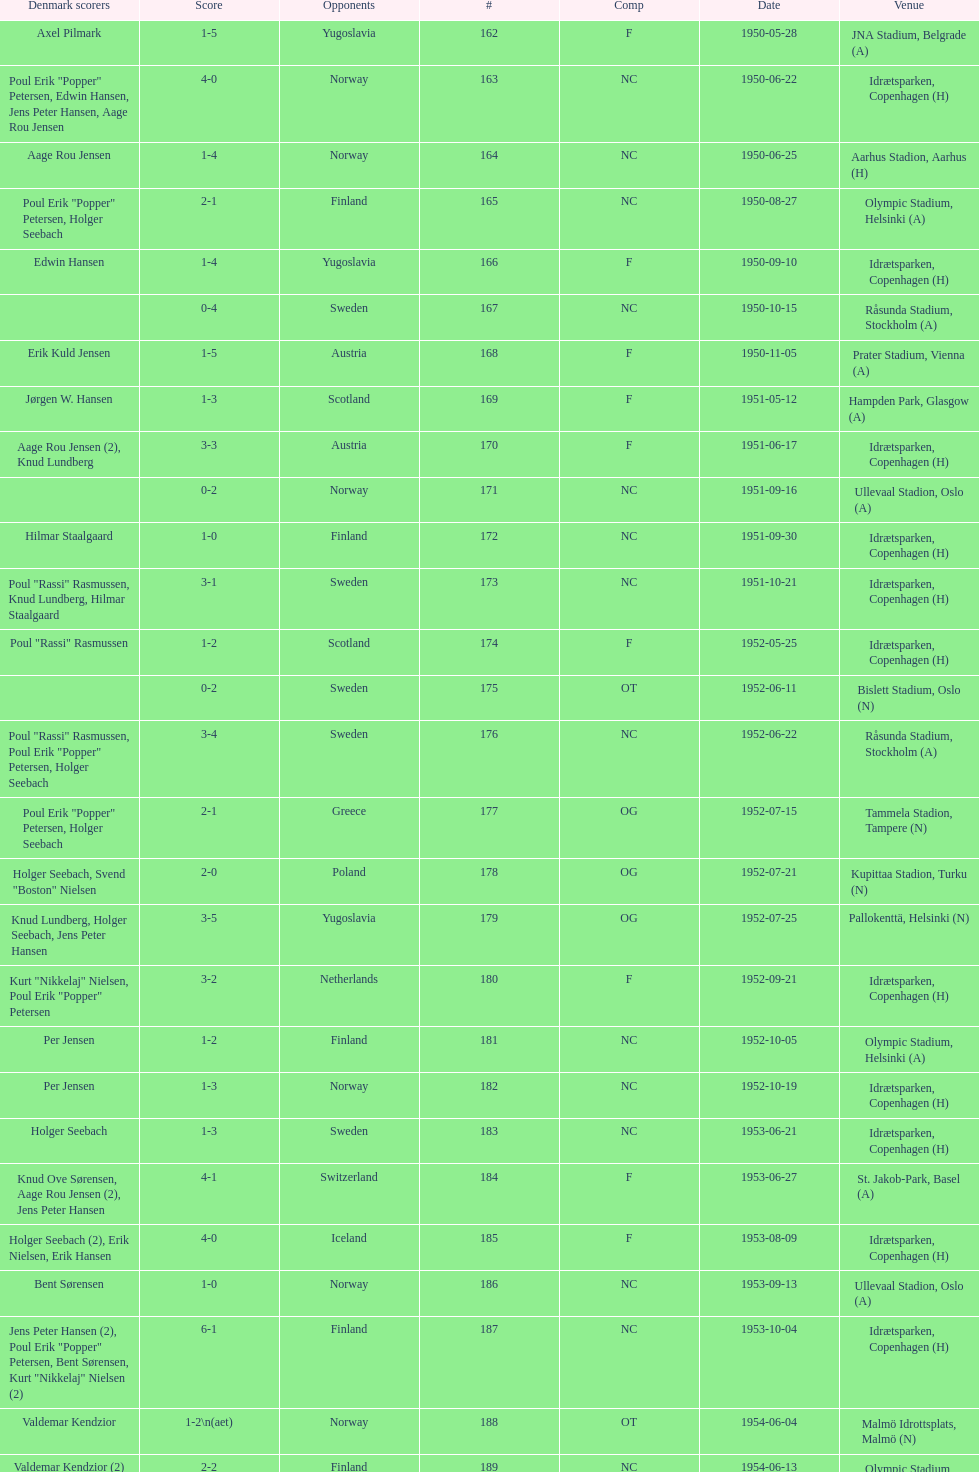Who did they compete against in the match mentioned right before july 25, 1952? Poland. 